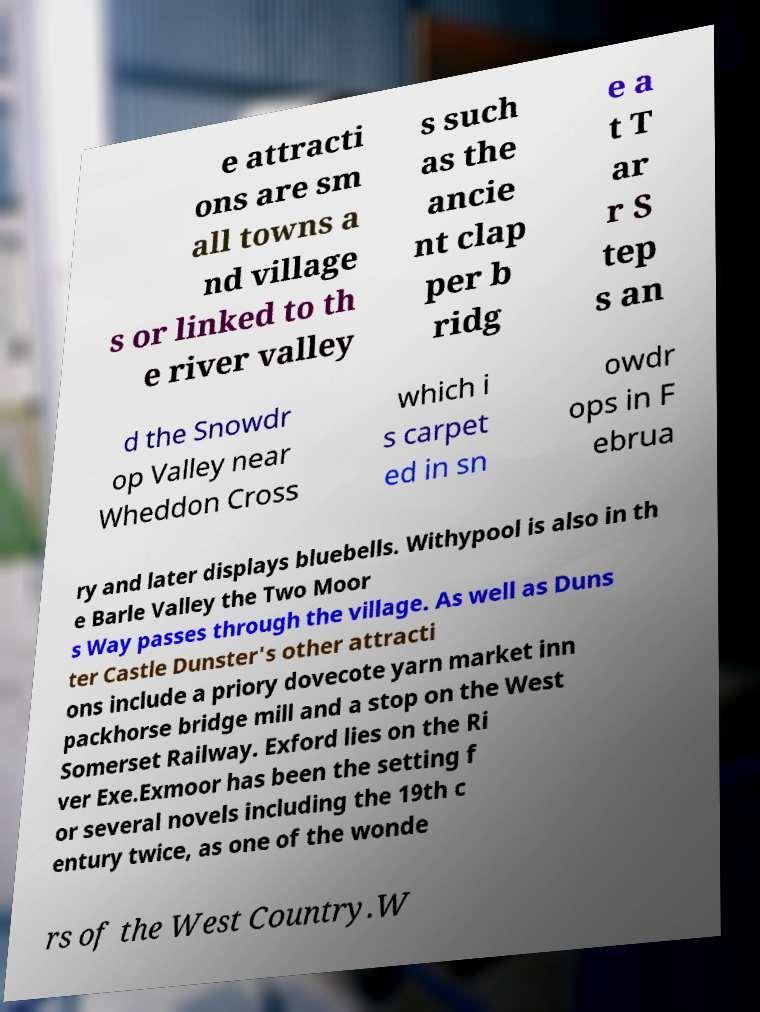For documentation purposes, I need the text within this image transcribed. Could you provide that? e attracti ons are sm all towns a nd village s or linked to th e river valley s such as the ancie nt clap per b ridg e a t T ar r S tep s an d the Snowdr op Valley near Wheddon Cross which i s carpet ed in sn owdr ops in F ebrua ry and later displays bluebells. Withypool is also in th e Barle Valley the Two Moor s Way passes through the village. As well as Duns ter Castle Dunster's other attracti ons include a priory dovecote yarn market inn packhorse bridge mill and a stop on the West Somerset Railway. Exford lies on the Ri ver Exe.Exmoor has been the setting f or several novels including the 19th c entury twice, as one of the wonde rs of the West Country.W 